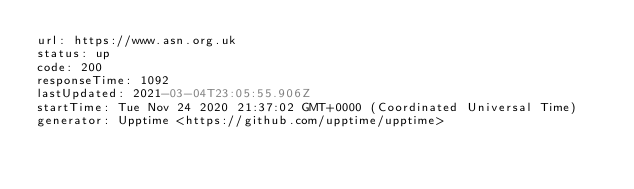<code> <loc_0><loc_0><loc_500><loc_500><_YAML_>url: https://www.asn.org.uk
status: up
code: 200
responseTime: 1092
lastUpdated: 2021-03-04T23:05:55.906Z
startTime: Tue Nov 24 2020 21:37:02 GMT+0000 (Coordinated Universal Time)
generator: Upptime <https://github.com/upptime/upptime>
</code> 